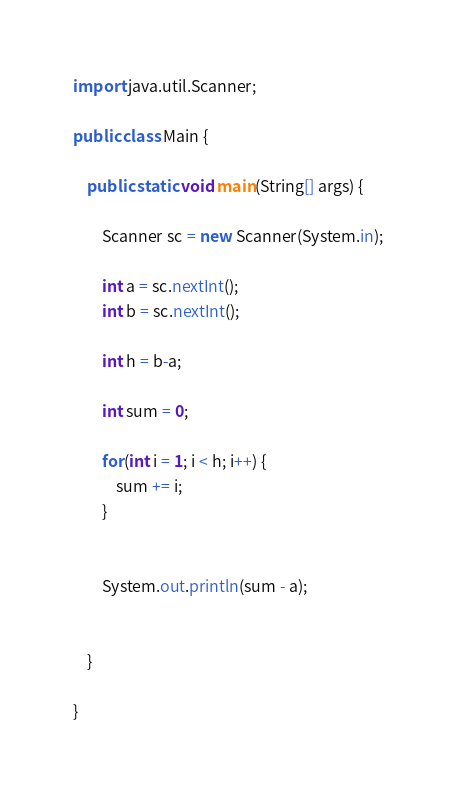Convert code to text. <code><loc_0><loc_0><loc_500><loc_500><_Java_>import java.util.Scanner;

public class Main {

	public static void main(String[] args) {

		Scanner sc = new Scanner(System.in);

		int a = sc.nextInt();
		int b = sc.nextInt();

		int h = b-a;

		int sum = 0;

		for(int i = 1; i < h; i++) {
			sum += i;
		}


		System.out.println(sum - a);


	}

}
</code> 